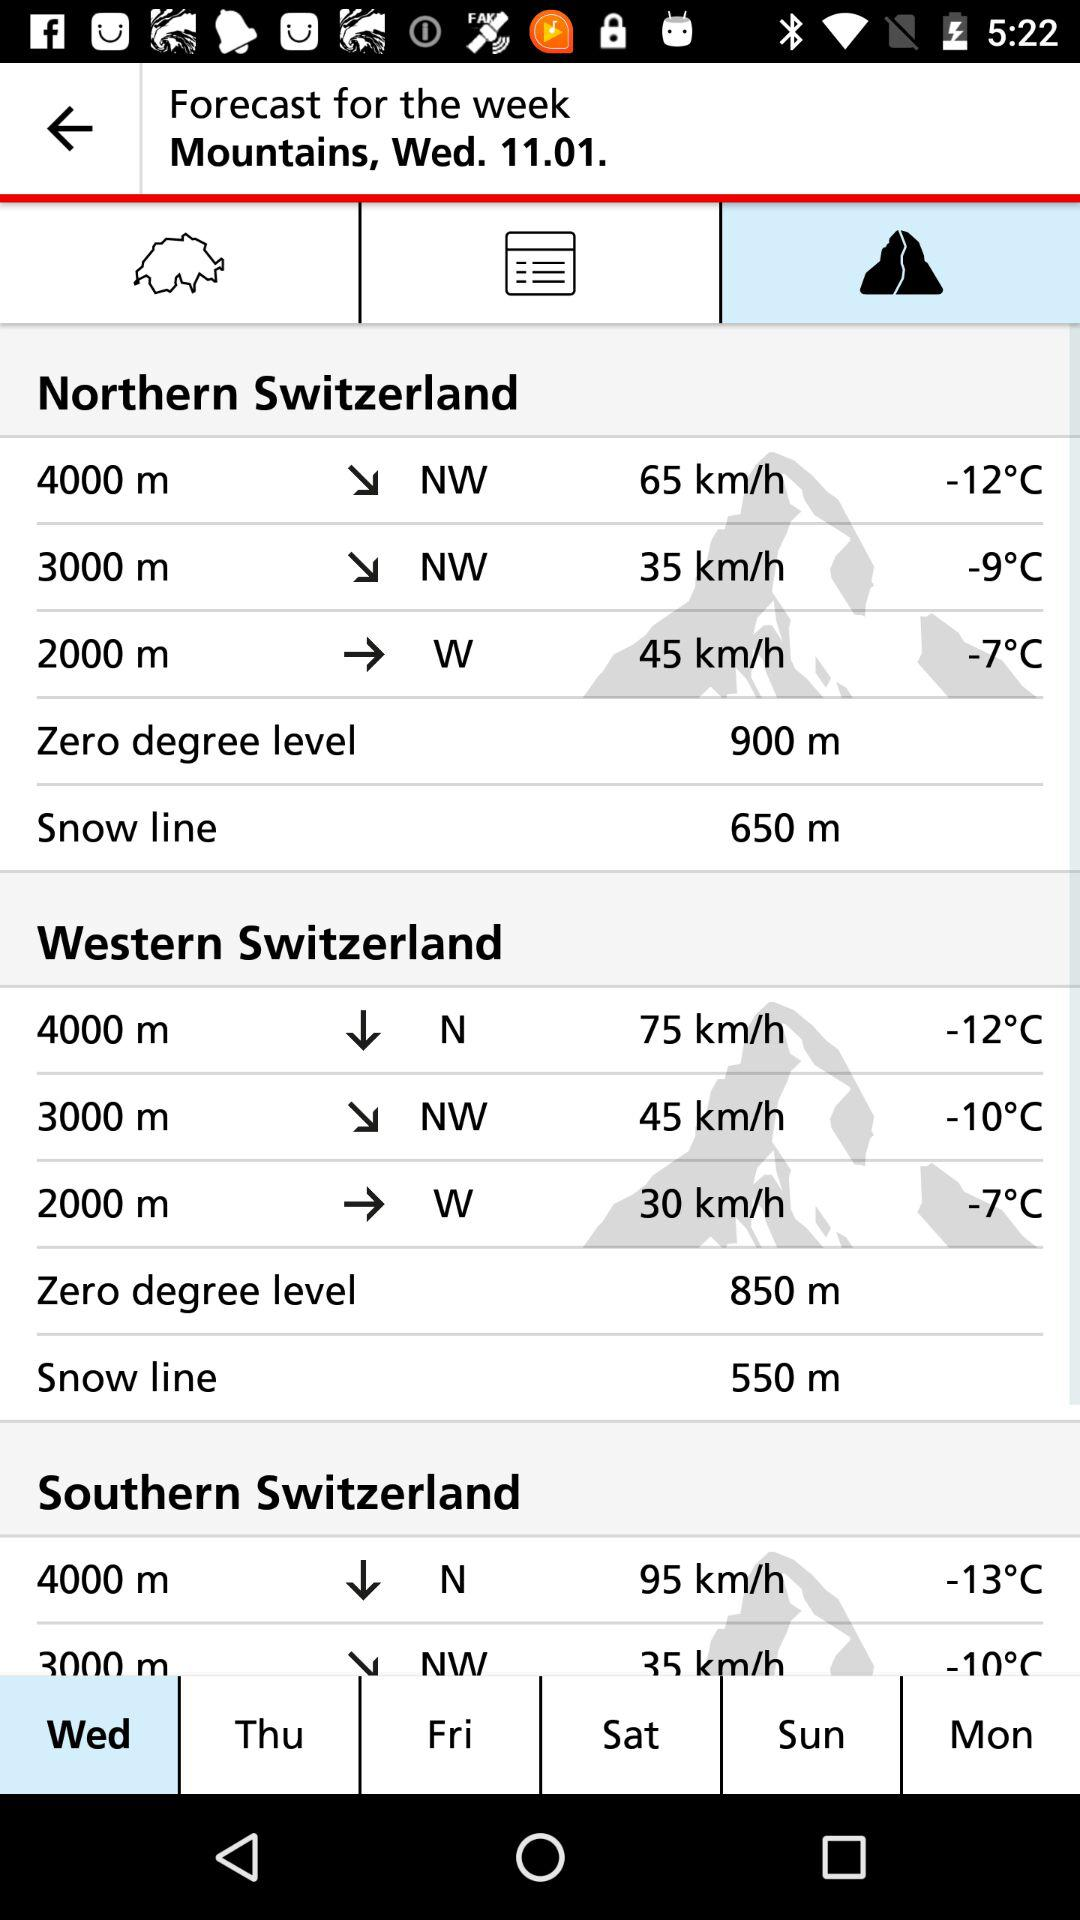How many more km/h is the wind speed at 4000m in southern Switzerland than in western Switzerland?
Answer the question using a single word or phrase. 20 